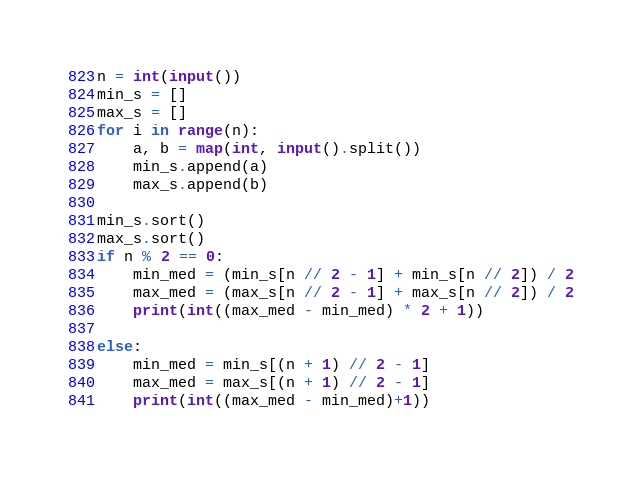<code> <loc_0><loc_0><loc_500><loc_500><_Python_>n = int(input())
min_s = []
max_s = []
for i in range(n):
    a, b = map(int, input().split())
    min_s.append(a)
    max_s.append(b)

min_s.sort()
max_s.sort()
if n % 2 == 0:
    min_med = (min_s[n // 2 - 1] + min_s[n // 2]) / 2
    max_med = (max_s[n // 2 - 1] + max_s[n // 2]) / 2
    print(int((max_med - min_med) * 2 + 1))

else:
    min_med = min_s[(n + 1) // 2 - 1]
    max_med = max_s[(n + 1) // 2 - 1]
    print(int((max_med - min_med)+1))</code> 